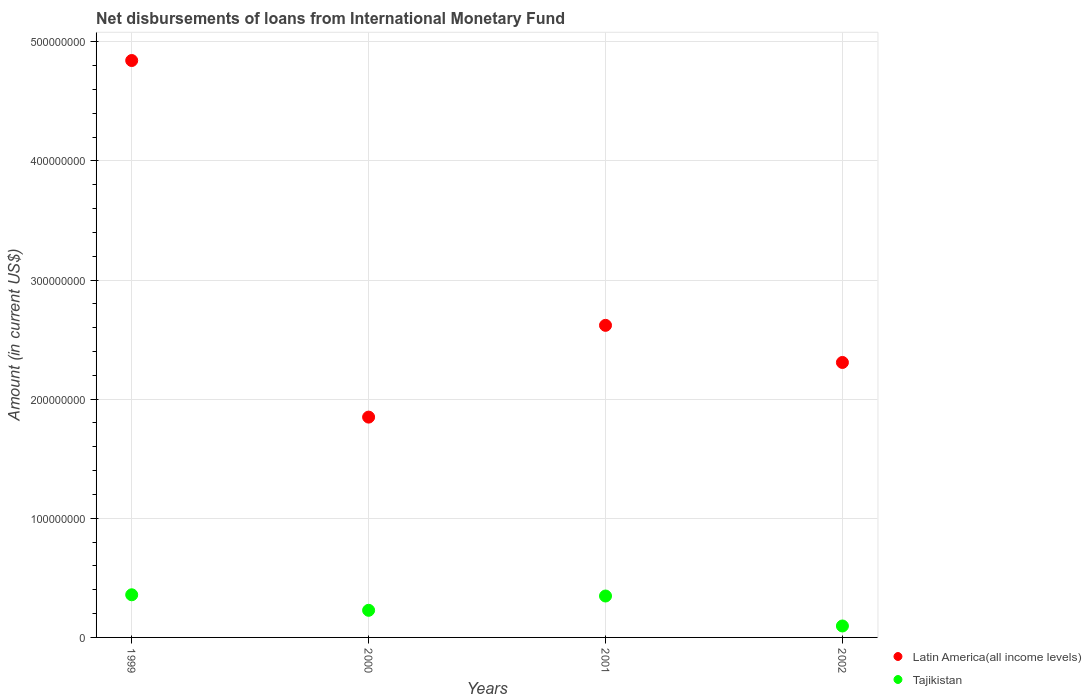Is the number of dotlines equal to the number of legend labels?
Make the answer very short. Yes. What is the amount of loans disbursed in Latin America(all income levels) in 1999?
Provide a short and direct response. 4.84e+08. Across all years, what is the maximum amount of loans disbursed in Tajikistan?
Offer a very short reply. 3.58e+07. Across all years, what is the minimum amount of loans disbursed in Tajikistan?
Your response must be concise. 9.60e+06. In which year was the amount of loans disbursed in Tajikistan minimum?
Your answer should be very brief. 2002. What is the total amount of loans disbursed in Tajikistan in the graph?
Offer a terse response. 1.03e+08. What is the difference between the amount of loans disbursed in Tajikistan in 2000 and that in 2002?
Provide a succinct answer. 1.32e+07. What is the difference between the amount of loans disbursed in Tajikistan in 1999 and the amount of loans disbursed in Latin America(all income levels) in 2001?
Ensure brevity in your answer.  -2.26e+08. What is the average amount of loans disbursed in Latin America(all income levels) per year?
Your answer should be compact. 2.90e+08. In the year 2002, what is the difference between the amount of loans disbursed in Latin America(all income levels) and amount of loans disbursed in Tajikistan?
Provide a short and direct response. 2.21e+08. In how many years, is the amount of loans disbursed in Latin America(all income levels) greater than 180000000 US$?
Give a very brief answer. 4. What is the ratio of the amount of loans disbursed in Latin America(all income levels) in 2000 to that in 2001?
Give a very brief answer. 0.71. What is the difference between the highest and the second highest amount of loans disbursed in Latin America(all income levels)?
Provide a short and direct response. 2.22e+08. What is the difference between the highest and the lowest amount of loans disbursed in Tajikistan?
Offer a terse response. 2.62e+07. Does the amount of loans disbursed in Tajikistan monotonically increase over the years?
Give a very brief answer. No. Is the amount of loans disbursed in Latin America(all income levels) strictly greater than the amount of loans disbursed in Tajikistan over the years?
Offer a terse response. Yes. How many dotlines are there?
Your answer should be very brief. 2. How many years are there in the graph?
Ensure brevity in your answer.  4. Are the values on the major ticks of Y-axis written in scientific E-notation?
Your answer should be very brief. No. Does the graph contain any zero values?
Your answer should be compact. No. Where does the legend appear in the graph?
Give a very brief answer. Bottom right. What is the title of the graph?
Ensure brevity in your answer.  Net disbursements of loans from International Monetary Fund. Does "Iraq" appear as one of the legend labels in the graph?
Your answer should be compact. No. What is the label or title of the X-axis?
Ensure brevity in your answer.  Years. What is the label or title of the Y-axis?
Offer a terse response. Amount (in current US$). What is the Amount (in current US$) of Latin America(all income levels) in 1999?
Keep it short and to the point. 4.84e+08. What is the Amount (in current US$) in Tajikistan in 1999?
Give a very brief answer. 3.58e+07. What is the Amount (in current US$) of Latin America(all income levels) in 2000?
Give a very brief answer. 1.85e+08. What is the Amount (in current US$) of Tajikistan in 2000?
Your answer should be very brief. 2.28e+07. What is the Amount (in current US$) in Latin America(all income levels) in 2001?
Provide a short and direct response. 2.62e+08. What is the Amount (in current US$) in Tajikistan in 2001?
Provide a short and direct response. 3.48e+07. What is the Amount (in current US$) in Latin America(all income levels) in 2002?
Make the answer very short. 2.31e+08. What is the Amount (in current US$) of Tajikistan in 2002?
Provide a short and direct response. 9.60e+06. Across all years, what is the maximum Amount (in current US$) in Latin America(all income levels)?
Provide a short and direct response. 4.84e+08. Across all years, what is the maximum Amount (in current US$) of Tajikistan?
Your answer should be compact. 3.58e+07. Across all years, what is the minimum Amount (in current US$) of Latin America(all income levels)?
Provide a succinct answer. 1.85e+08. Across all years, what is the minimum Amount (in current US$) of Tajikistan?
Your answer should be compact. 9.60e+06. What is the total Amount (in current US$) in Latin America(all income levels) in the graph?
Your answer should be compact. 1.16e+09. What is the total Amount (in current US$) in Tajikistan in the graph?
Your answer should be compact. 1.03e+08. What is the difference between the Amount (in current US$) of Latin America(all income levels) in 1999 and that in 2000?
Your answer should be compact. 2.99e+08. What is the difference between the Amount (in current US$) of Tajikistan in 1999 and that in 2000?
Give a very brief answer. 1.30e+07. What is the difference between the Amount (in current US$) of Latin America(all income levels) in 1999 and that in 2001?
Offer a very short reply. 2.22e+08. What is the difference between the Amount (in current US$) of Tajikistan in 1999 and that in 2001?
Make the answer very short. 1.03e+06. What is the difference between the Amount (in current US$) in Latin America(all income levels) in 1999 and that in 2002?
Your answer should be very brief. 2.53e+08. What is the difference between the Amount (in current US$) of Tajikistan in 1999 and that in 2002?
Provide a short and direct response. 2.62e+07. What is the difference between the Amount (in current US$) in Latin America(all income levels) in 2000 and that in 2001?
Make the answer very short. -7.70e+07. What is the difference between the Amount (in current US$) in Tajikistan in 2000 and that in 2001?
Give a very brief answer. -1.20e+07. What is the difference between the Amount (in current US$) of Latin America(all income levels) in 2000 and that in 2002?
Keep it short and to the point. -4.59e+07. What is the difference between the Amount (in current US$) of Tajikistan in 2000 and that in 2002?
Offer a terse response. 1.32e+07. What is the difference between the Amount (in current US$) in Latin America(all income levels) in 2001 and that in 2002?
Make the answer very short. 3.12e+07. What is the difference between the Amount (in current US$) in Tajikistan in 2001 and that in 2002?
Your answer should be compact. 2.52e+07. What is the difference between the Amount (in current US$) in Latin America(all income levels) in 1999 and the Amount (in current US$) in Tajikistan in 2000?
Keep it short and to the point. 4.61e+08. What is the difference between the Amount (in current US$) of Latin America(all income levels) in 1999 and the Amount (in current US$) of Tajikistan in 2001?
Provide a succinct answer. 4.49e+08. What is the difference between the Amount (in current US$) in Latin America(all income levels) in 1999 and the Amount (in current US$) in Tajikistan in 2002?
Make the answer very short. 4.75e+08. What is the difference between the Amount (in current US$) in Latin America(all income levels) in 2000 and the Amount (in current US$) in Tajikistan in 2001?
Provide a short and direct response. 1.50e+08. What is the difference between the Amount (in current US$) of Latin America(all income levels) in 2000 and the Amount (in current US$) of Tajikistan in 2002?
Your answer should be compact. 1.75e+08. What is the difference between the Amount (in current US$) in Latin America(all income levels) in 2001 and the Amount (in current US$) in Tajikistan in 2002?
Provide a short and direct response. 2.52e+08. What is the average Amount (in current US$) in Latin America(all income levels) per year?
Offer a very short reply. 2.90e+08. What is the average Amount (in current US$) in Tajikistan per year?
Provide a short and direct response. 2.57e+07. In the year 1999, what is the difference between the Amount (in current US$) in Latin America(all income levels) and Amount (in current US$) in Tajikistan?
Make the answer very short. 4.48e+08. In the year 2000, what is the difference between the Amount (in current US$) in Latin America(all income levels) and Amount (in current US$) in Tajikistan?
Your response must be concise. 1.62e+08. In the year 2001, what is the difference between the Amount (in current US$) in Latin America(all income levels) and Amount (in current US$) in Tajikistan?
Ensure brevity in your answer.  2.27e+08. In the year 2002, what is the difference between the Amount (in current US$) of Latin America(all income levels) and Amount (in current US$) of Tajikistan?
Your answer should be compact. 2.21e+08. What is the ratio of the Amount (in current US$) of Latin America(all income levels) in 1999 to that in 2000?
Your answer should be very brief. 2.62. What is the ratio of the Amount (in current US$) of Tajikistan in 1999 to that in 2000?
Offer a terse response. 1.57. What is the ratio of the Amount (in current US$) of Latin America(all income levels) in 1999 to that in 2001?
Ensure brevity in your answer.  1.85. What is the ratio of the Amount (in current US$) in Tajikistan in 1999 to that in 2001?
Your answer should be compact. 1.03. What is the ratio of the Amount (in current US$) of Latin America(all income levels) in 1999 to that in 2002?
Your answer should be very brief. 2.1. What is the ratio of the Amount (in current US$) in Tajikistan in 1999 to that in 2002?
Provide a short and direct response. 3.73. What is the ratio of the Amount (in current US$) of Latin America(all income levels) in 2000 to that in 2001?
Your answer should be compact. 0.71. What is the ratio of the Amount (in current US$) of Tajikistan in 2000 to that in 2001?
Give a very brief answer. 0.66. What is the ratio of the Amount (in current US$) in Latin America(all income levels) in 2000 to that in 2002?
Your response must be concise. 0.8. What is the ratio of the Amount (in current US$) of Tajikistan in 2000 to that in 2002?
Ensure brevity in your answer.  2.37. What is the ratio of the Amount (in current US$) in Latin America(all income levels) in 2001 to that in 2002?
Keep it short and to the point. 1.14. What is the ratio of the Amount (in current US$) in Tajikistan in 2001 to that in 2002?
Your answer should be compact. 3.62. What is the difference between the highest and the second highest Amount (in current US$) in Latin America(all income levels)?
Give a very brief answer. 2.22e+08. What is the difference between the highest and the second highest Amount (in current US$) of Tajikistan?
Offer a very short reply. 1.03e+06. What is the difference between the highest and the lowest Amount (in current US$) of Latin America(all income levels)?
Provide a succinct answer. 2.99e+08. What is the difference between the highest and the lowest Amount (in current US$) of Tajikistan?
Your answer should be compact. 2.62e+07. 